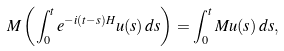<formula> <loc_0><loc_0><loc_500><loc_500>M \left ( \int _ { 0 } ^ { t } e ^ { - i ( t - s ) H } u ( s ) \, d s \right ) = \int _ { 0 } ^ { t } M u ( s ) \, d s ,</formula> 